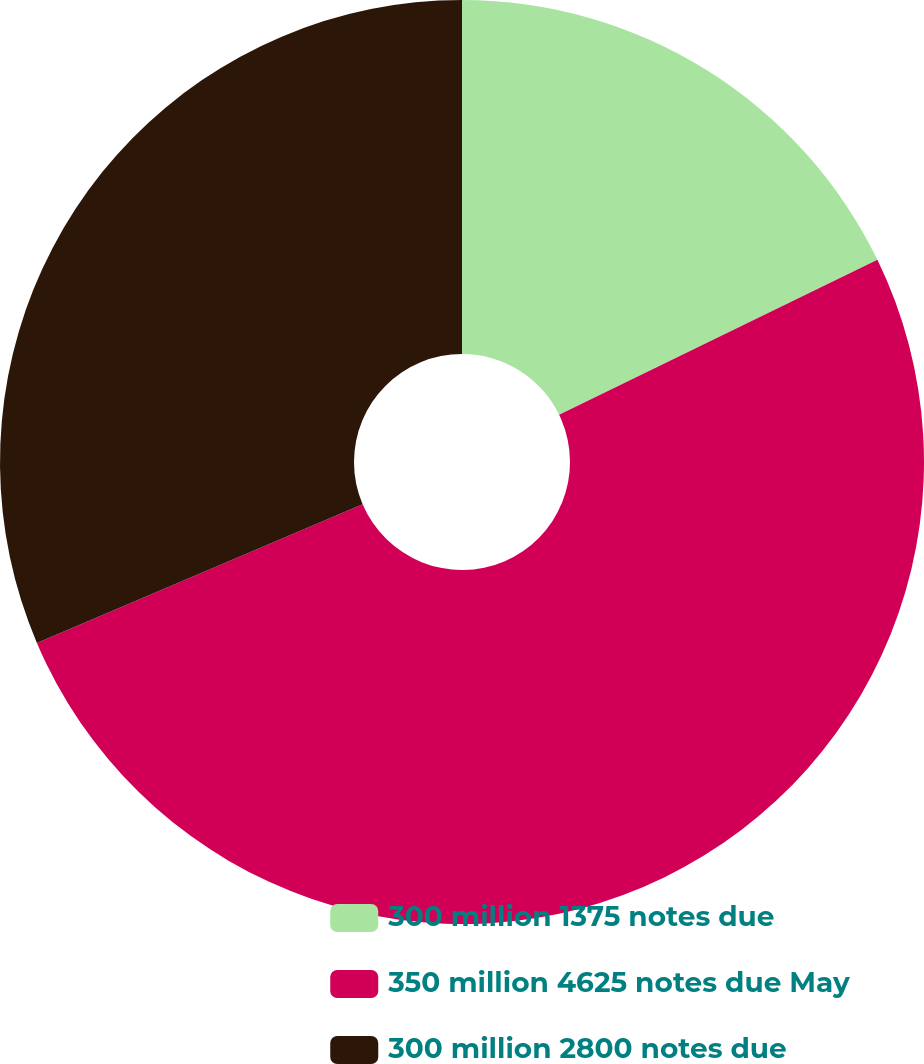Convert chart. <chart><loc_0><loc_0><loc_500><loc_500><pie_chart><fcel>300 million 1375 notes due<fcel>350 million 4625 notes due May<fcel>300 million 2800 notes due<nl><fcel>17.79%<fcel>50.8%<fcel>31.4%<nl></chart> 